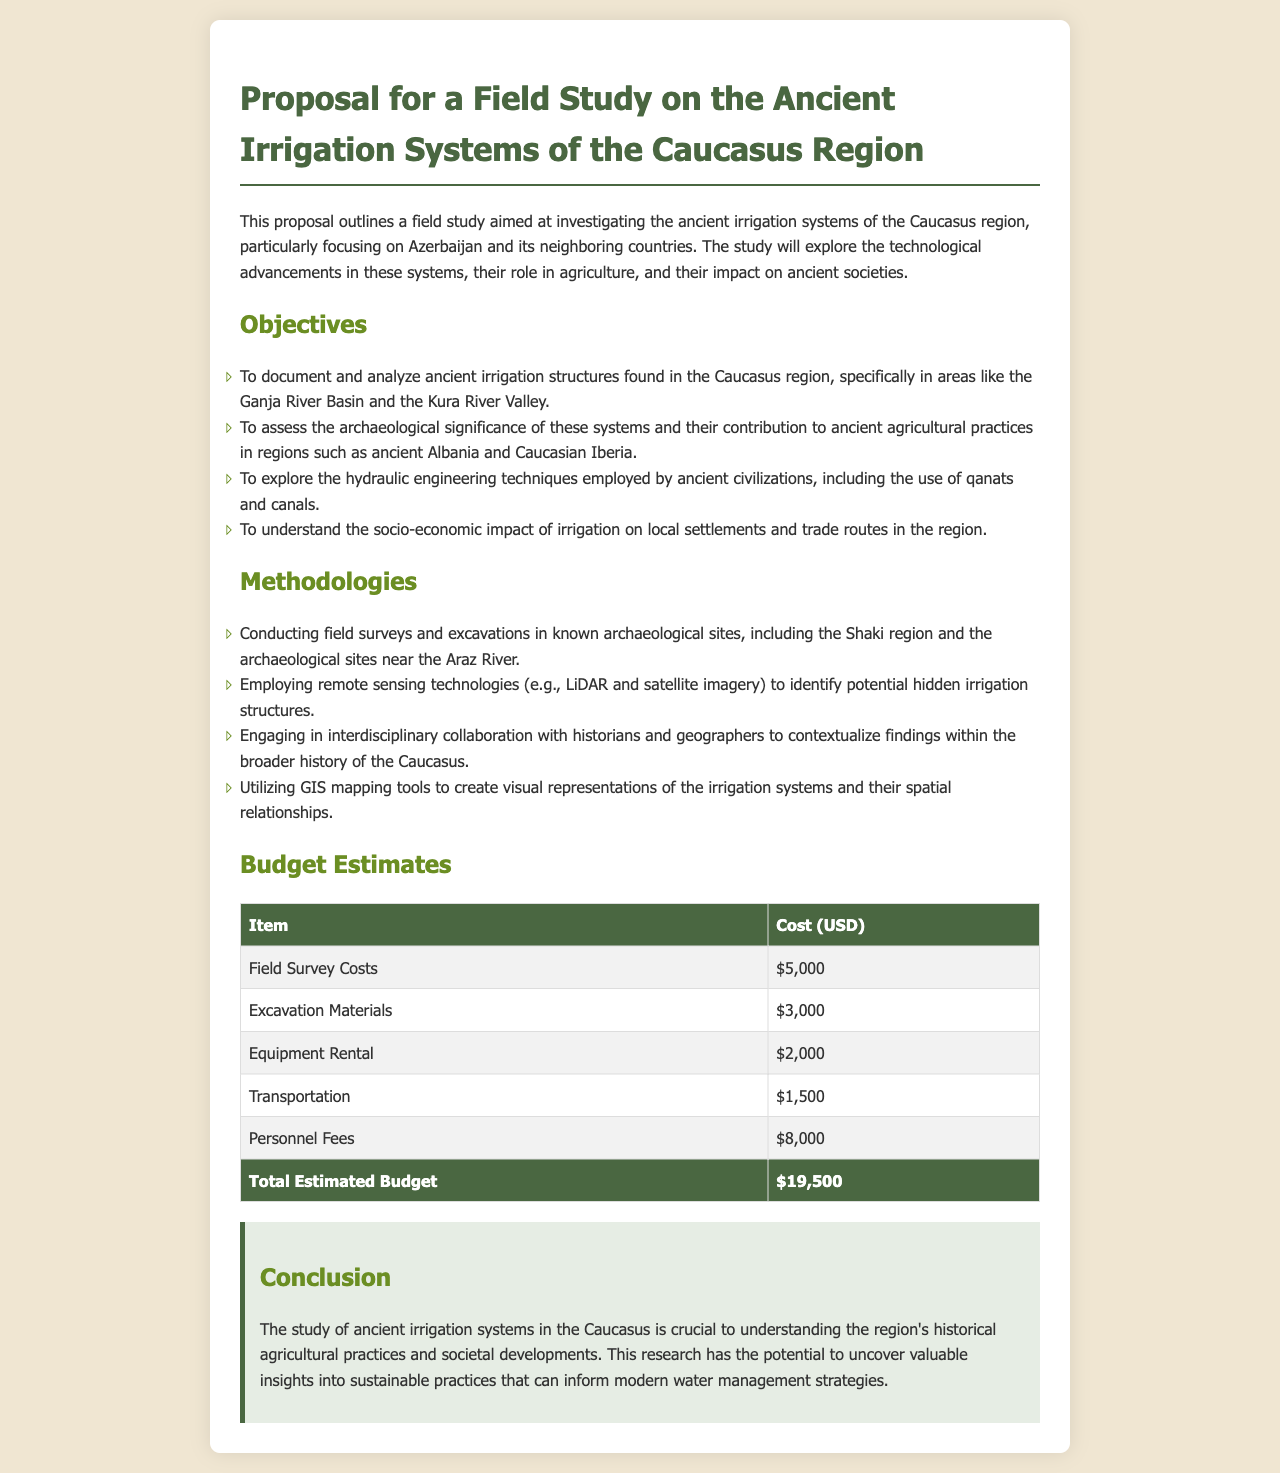What is the title of the proposal? The title of the proposal is explicitly mentioned at the top of the document.
Answer: Proposal for a Field Study on the Ancient Irrigation Systems of the Caucasus Region How much is the total estimated budget? The total estimated budget is calculated as the sum of all item costs listed in the budget estimates section.
Answer: $19,500 Which regions are specifically mentioned for field surveys? The document lists specific regions where field surveys are intended to take place.
Answer: Ganja River Basin and Kura River Valley What is one method used to identify hidden irrigation structures? The document mentions a specific technology that will be utilized for this purpose.
Answer: Remote sensing technologies What is the purpose of engaging with historians and geographers in this study? The proposal explains the reason for collaborating with these experts to enhance the study.
Answer: To contextualize findings within the broader history of the Caucasus Name an ancient civilization technique mentioned in the objectives. The objectives outline specific techniques used by ancient civilizations in irrigation.
Answer: Qanats How many objectives are listed in the document? The number of objectives can be counted from the listed items in the objectives section.
Answer: Four 